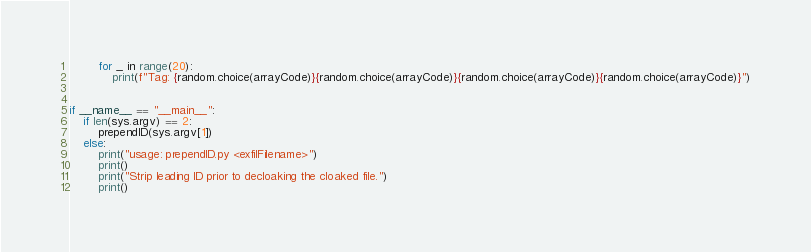<code> <loc_0><loc_0><loc_500><loc_500><_Python_>		for _ in range(20):
			print(f"Tag: {random.choice(arrayCode)}{random.choice(arrayCode)}{random.choice(arrayCode)}{random.choice(arrayCode)}")


if __name__ == "__main__":
	if len(sys.argv) == 2:
		prependID(sys.argv[1])
	else:
		print("usage: prependID.py <exfilFilename>")
		print()
		print("Strip leading ID prior to decloaking the cloaked file.")
		print()

</code> 